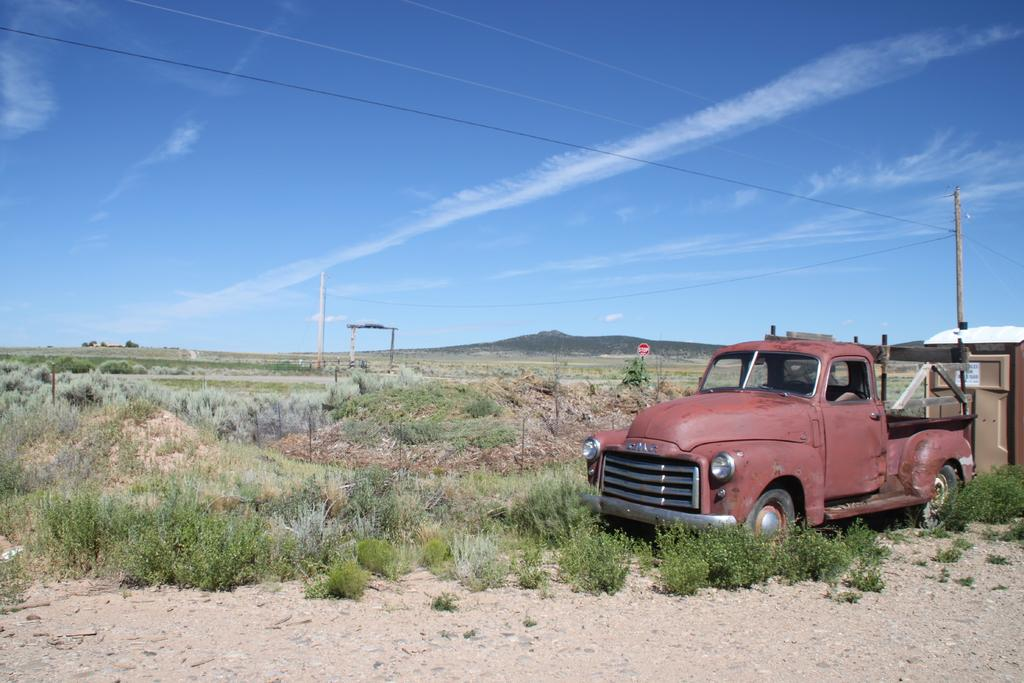What structure is located on the right side of the image? There is a building on the right side of the image. What vehicle can be seen on the right side of the image? There is a car on the right side of the image. What object is present in the image that is typically used for supporting signs or lights? There is a pole in the image. What type of vegetation is present on the ground in the image? Grass is present on the ground in the image. What is visible in the background of the image? The sky is visible in the background of the image. What can be seen in the sky in the image? Clouds are present in the sky. How many chairs are placed on the grass in the image? There are no chairs mentioned in the image. What type of pizzas can be seen in the image? There are no pizzas mentioned in the image. 